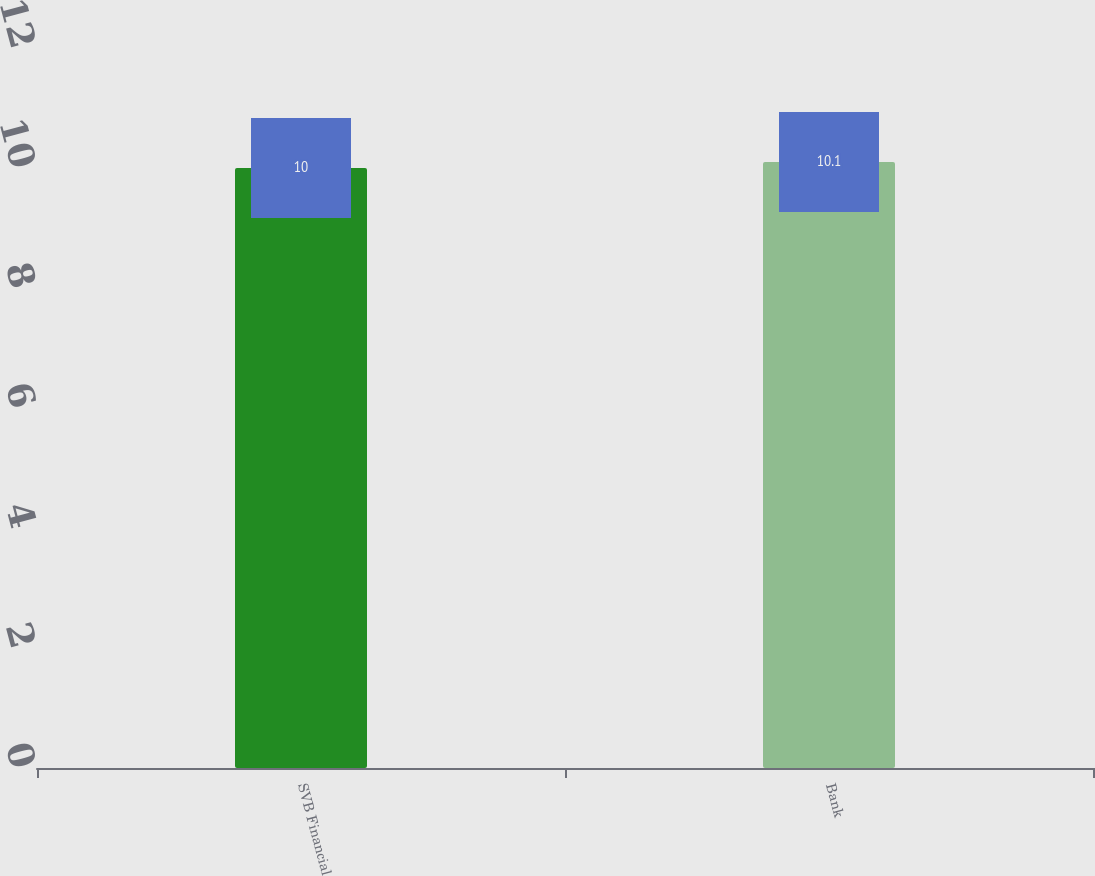<chart> <loc_0><loc_0><loc_500><loc_500><bar_chart><fcel>SVB Financial<fcel>Bank<nl><fcel>10<fcel>10.1<nl></chart> 